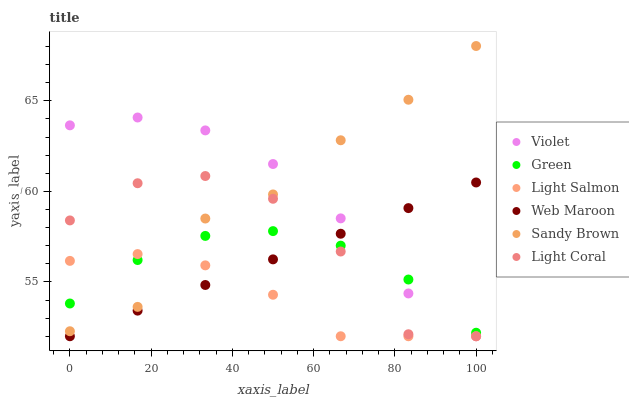Does Light Salmon have the minimum area under the curve?
Answer yes or no. Yes. Does Sandy Brown have the maximum area under the curve?
Answer yes or no. Yes. Does Web Maroon have the minimum area under the curve?
Answer yes or no. No. Does Web Maroon have the maximum area under the curve?
Answer yes or no. No. Is Web Maroon the smoothest?
Answer yes or no. Yes. Is Light Coral the roughest?
Answer yes or no. Yes. Is Light Coral the smoothest?
Answer yes or no. No. Is Web Maroon the roughest?
Answer yes or no. No. Does Light Salmon have the lowest value?
Answer yes or no. Yes. Does Green have the lowest value?
Answer yes or no. No. Does Sandy Brown have the highest value?
Answer yes or no. Yes. Does Web Maroon have the highest value?
Answer yes or no. No. Is Web Maroon less than Sandy Brown?
Answer yes or no. Yes. Is Sandy Brown greater than Web Maroon?
Answer yes or no. Yes. Does Light Salmon intersect Light Coral?
Answer yes or no. Yes. Is Light Salmon less than Light Coral?
Answer yes or no. No. Is Light Salmon greater than Light Coral?
Answer yes or no. No. Does Web Maroon intersect Sandy Brown?
Answer yes or no. No. 